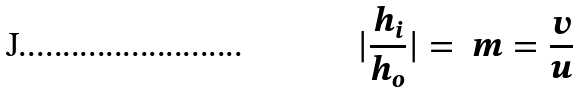Convert formula to latex. <formula><loc_0><loc_0><loc_500><loc_500>| \frac { h _ { i } } { h _ { o } } | = \ m = \frac { v } { u }</formula> 